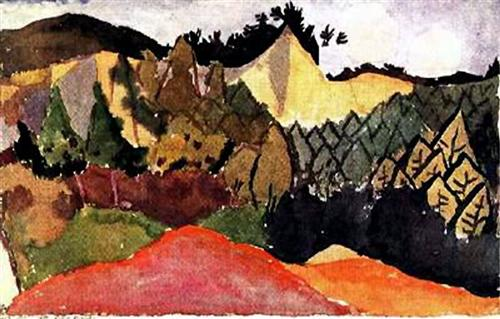What time of day does it seem to depict? The painting appears to capture either dawn or dusk, as suggested by the warm tones and long shadows cast by the peaks. The light seems soft and diffused, perhaps indicating the sun's position just below or above the horizon, lending an air of quietude to the scene. How does the color palette affect the mood of the piece? The color palette, with its rich and warm hues, establishes an inviting and uplifting mood. The choice of reds and yellows imbues the landscape with a sense of energy and vibrancy, while the cooler greens add balance and depth, creating an overall feeling of harmony and artistic exuberance. 